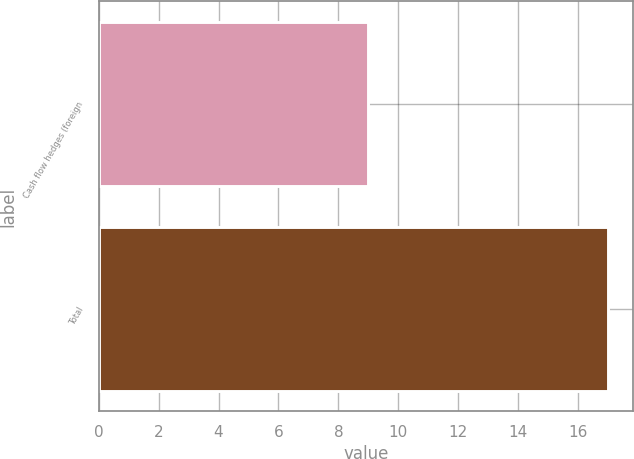Convert chart to OTSL. <chart><loc_0><loc_0><loc_500><loc_500><bar_chart><fcel>Cash flow hedges (foreign<fcel>Total<nl><fcel>9<fcel>17<nl></chart> 